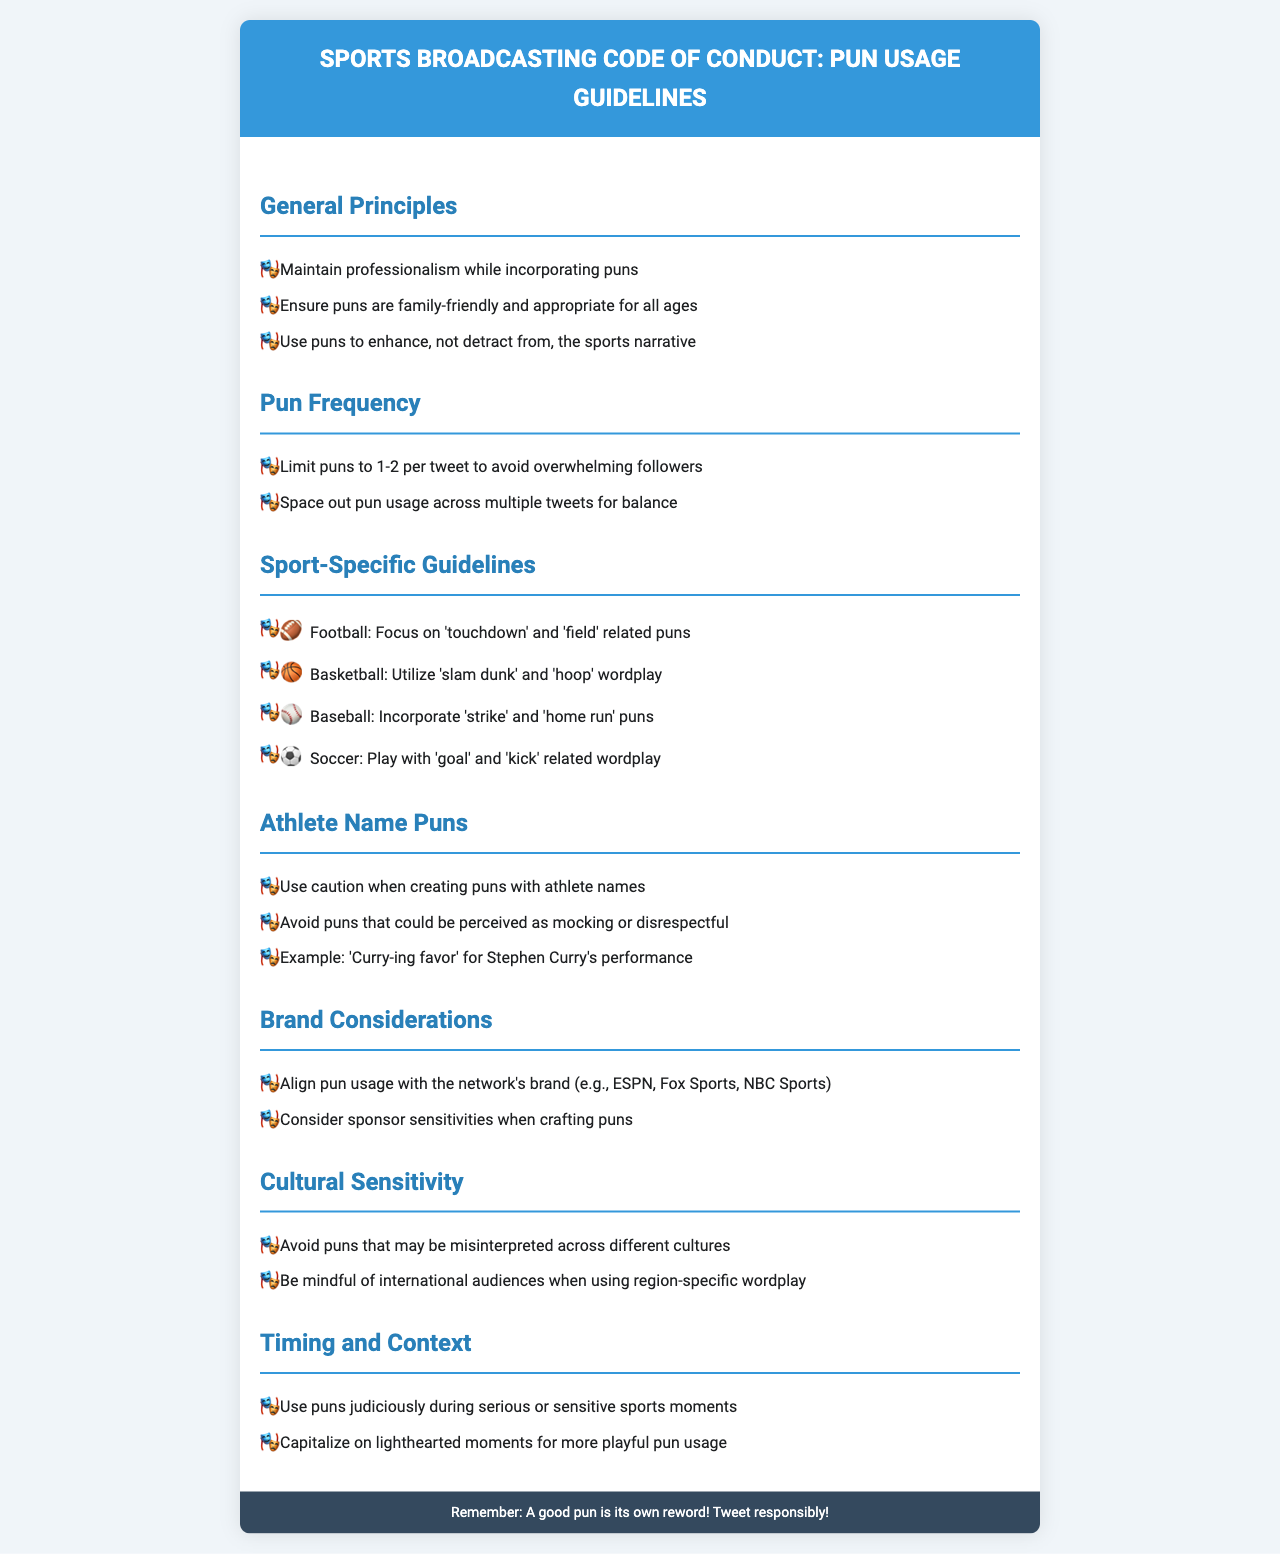what is the maximum number of puns recommended per tweet? The document states that limiting puns to 1-2 per tweet is advised to avoid overwhelming followers.
Answer: 1-2 what symbol is used before each list item? The document specifies that a mask emoji is used before each list item.
Answer: 🎭 which sport is associated with 'slam dunk' puns? The guidelines mention that 'slam dunk' puns are relevant for basketball.
Answer: Basketball what should be avoided when creating puns with athlete names? The document advises avoiding puns that could be perceived as mocking or disrespectful.
Answer: Mocking or disrespectful how many guidelines are there under the Sport-Specific Guidelines section? The document lists four sports under the Sport-Specific Guidelines section, each with its own pun-related advice.
Answer: 4 what is the main cultural concern when using puns? The document emphasizes avoiding puns that may be misinterpreted across different cultures.
Answer: Misinterpretation when is more playful pun usage recommended? The document suggests capitalizing on lighthearted moments for more playful pun usage.
Answer: Lighthearted moments how should pun usage align with network considerations? The document specifies that pun usage should align with the network's brand.
Answer: Network's brand what is a key factor to consider regarding sponsor sensitivities? The guidelines state that pun usage should consider sponsor sensitivities when crafting puns.
Answer: Sponsor sensitivities 